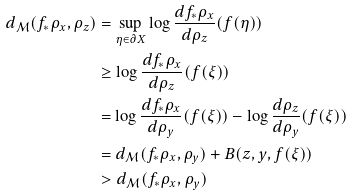<formula> <loc_0><loc_0><loc_500><loc_500>d _ { \mathcal { M } } ( f _ { * } \rho _ { x } , \rho _ { z } ) & = \sup _ { \eta \in \partial X } \log \frac { d f _ { * } \rho _ { x } } { d \rho _ { z } } ( f ( \eta ) ) \\ & \geq \log \frac { d f _ { * } \rho _ { x } } { d \rho _ { z } } ( f ( \xi ) ) \\ & = \log \frac { d f _ { * } \rho _ { x } } { d \rho _ { y } } ( f ( \xi ) ) - \log \frac { d \rho _ { z } } { d \rho _ { y } } ( f ( \xi ) ) \\ & = d _ { \mathcal { M } } ( f _ { * } \rho _ { x } , \rho _ { y } ) + B ( z , y , f ( \xi ) ) \\ & > d _ { \mathcal { M } } ( f _ { * } \rho _ { x } , \rho _ { y } ) \\</formula> 